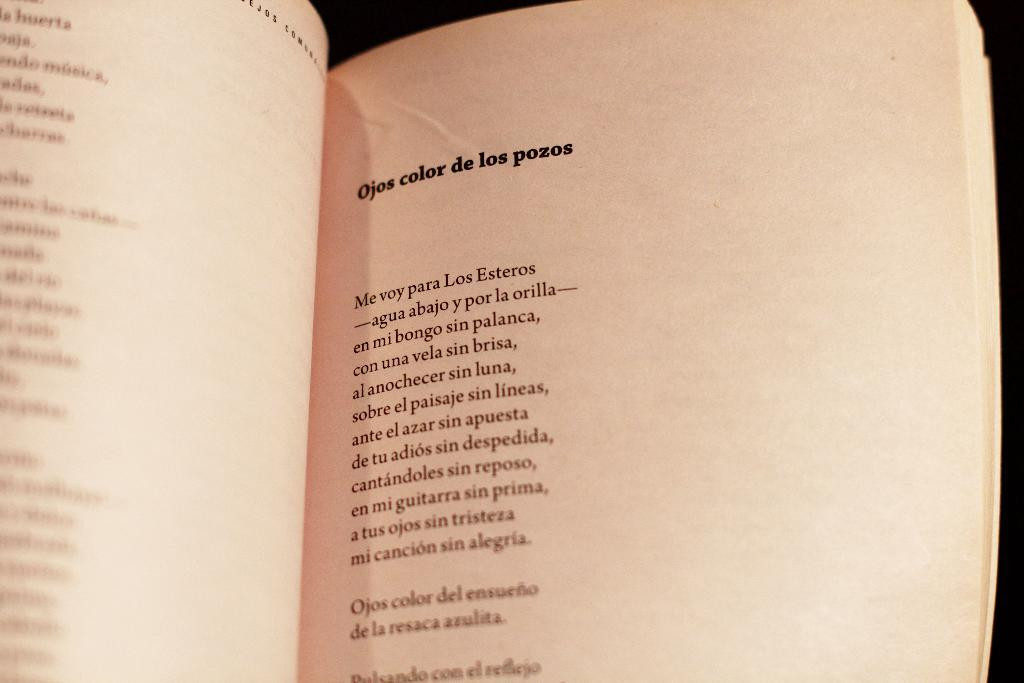<image>
Provide a brief description of the given image. A page of a book with the words Ojos color de los pozos on it 